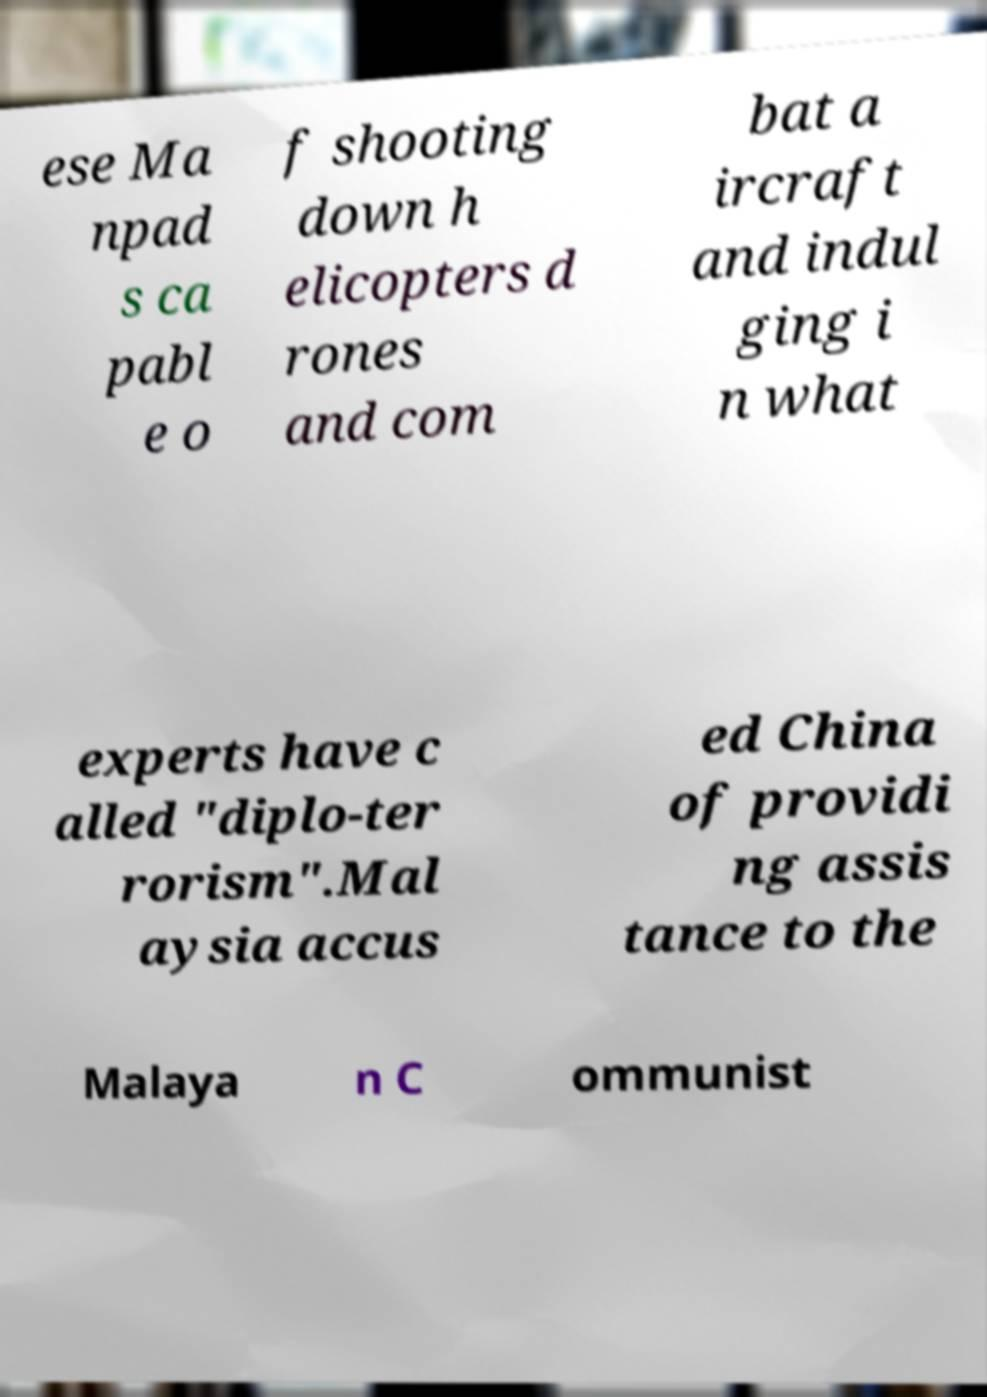Can you read and provide the text displayed in the image?This photo seems to have some interesting text. Can you extract and type it out for me? ese Ma npad s ca pabl e o f shooting down h elicopters d rones and com bat a ircraft and indul ging i n what experts have c alled "diplo-ter rorism".Mal aysia accus ed China of providi ng assis tance to the Malaya n C ommunist 